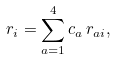Convert formula to latex. <formula><loc_0><loc_0><loc_500><loc_500>r _ { i } = \sum _ { a = 1 } ^ { 4 } c _ { a } \, r _ { a i } ,</formula> 